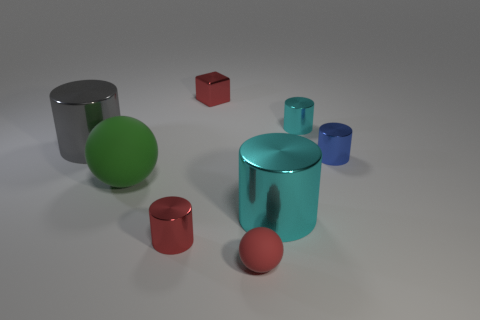Is the size of the cyan metal object that is in front of the blue metallic cylinder the same as the red metallic cube that is behind the gray cylinder? The cyan object appears to be a cylindrical shape with a larger diameter but shorter height compared to the red cube. However, without exact measurements it's difficult to determine volume equivalence, but visually, they do not appear to be the same size. 